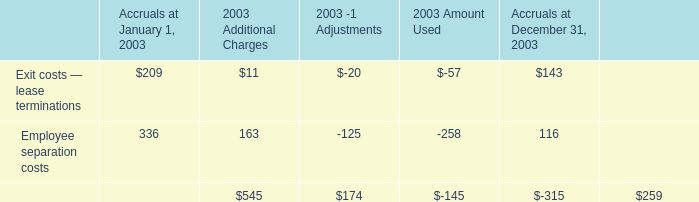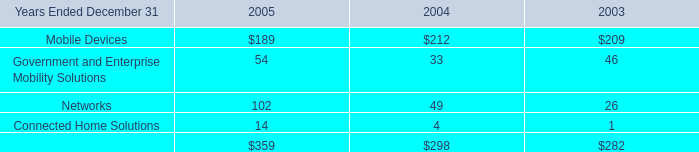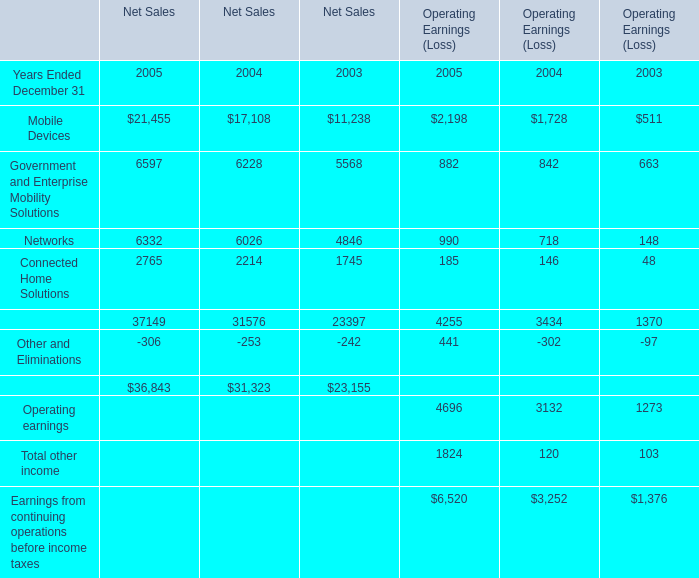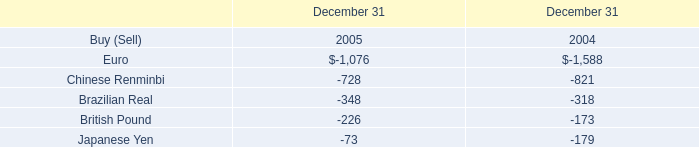What is the sum of the Networks in the years where Connected Home Solutions greater than 1? 
Computations: (102 + 49)
Answer: 151.0. 